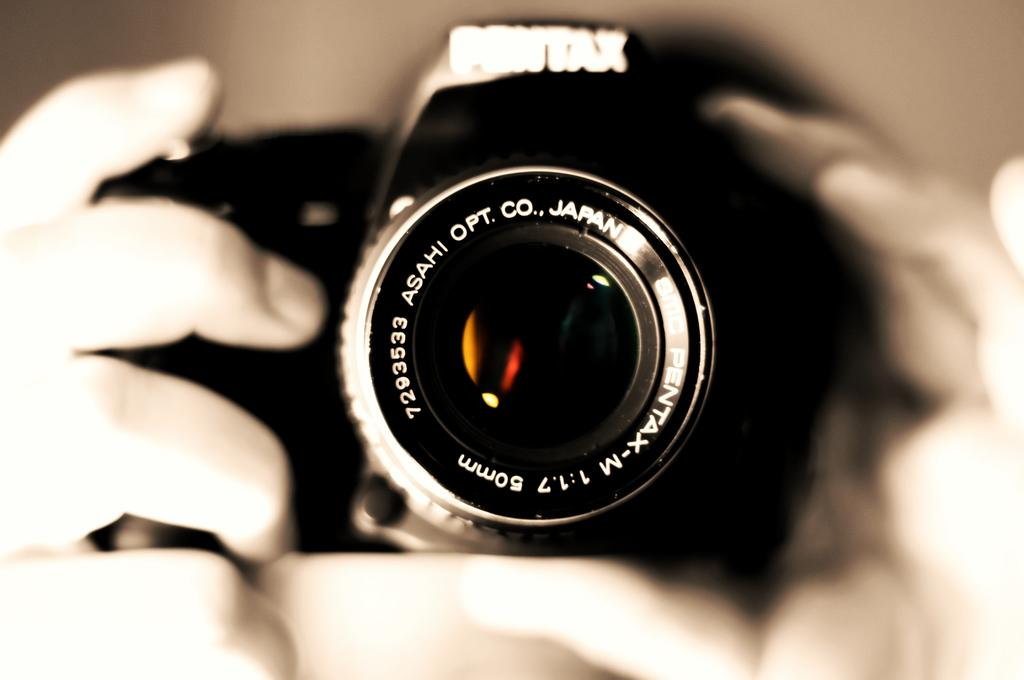What is the main subject of the image? There is a person in the image. What is the person holding in the image? The person is holding a camera. How much learning material is visible on the shelf in the image? There is no shelf or learning material present in the image. 